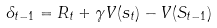<formula> <loc_0><loc_0><loc_500><loc_500>\delta _ { t - 1 } = R _ { t } + \gamma V ( s _ { t } ) - V ( S _ { t - 1 } )</formula> 